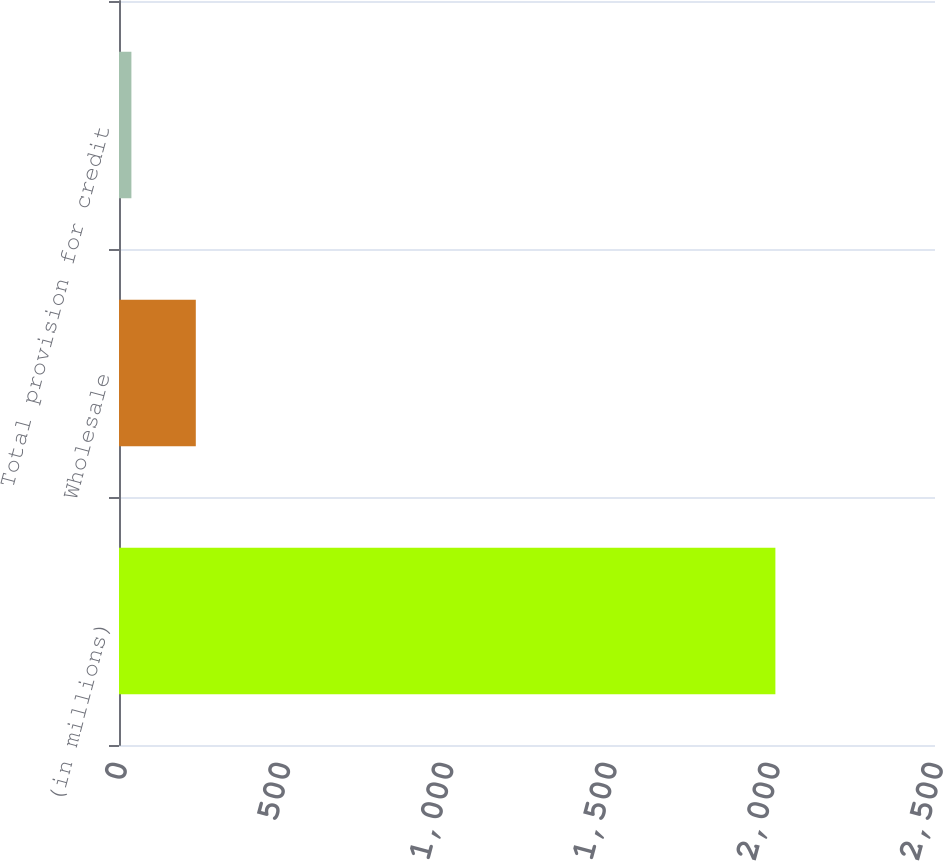Convert chart to OTSL. <chart><loc_0><loc_0><loc_500><loc_500><bar_chart><fcel>(in millions)<fcel>Wholesale<fcel>Total provision for credit<nl><fcel>2011<fcel>235.3<fcel>38<nl></chart> 